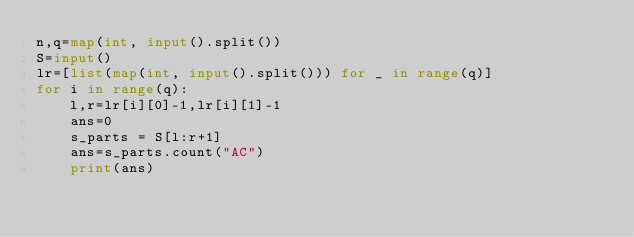Convert code to text. <code><loc_0><loc_0><loc_500><loc_500><_Python_>n,q=map(int, input().split())
S=input()
lr=[list(map(int, input().split())) for _ in range(q)]
for i in range(q):
    l,r=lr[i][0]-1,lr[i][1]-1
    ans=0
    s_parts = S[l:r+1]
    ans=s_parts.count("AC")
    print(ans)</code> 